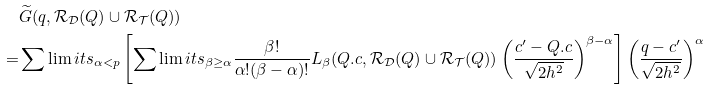Convert formula to latex. <formula><loc_0><loc_0><loc_500><loc_500>& \widetilde { G } ( q , \mathcal { R _ { D } } ( Q ) \cup \mathcal { R _ { T } } ( Q ) ) \\ = & \sum \lim i t s _ { \alpha < p } \left [ \sum \lim i t s _ { \beta \geq \alpha } \frac { \beta ! } { \alpha ! ( \beta - \alpha ) ! } L _ { \beta } ( Q . c , \mathcal { R _ { D } } ( Q ) \cup \mathcal { R _ { T } } ( Q ) ) \left ( \frac { c ^ { \prime } - Q . c } { \sqrt { 2 h ^ { 2 } } } \right ) ^ { \beta - \alpha } \right ] \left ( \frac { q - c ^ { \prime } } { \sqrt { 2 h ^ { 2 } } } \right ) ^ { \alpha }</formula> 